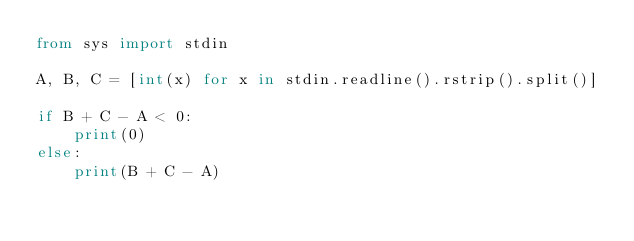<code> <loc_0><loc_0><loc_500><loc_500><_Python_>from sys import stdin

A, B, C = [int(x) for x in stdin.readline().rstrip().split()]

if B + C - A < 0:
    print(0)
else:
    print(B + C - A)
</code> 